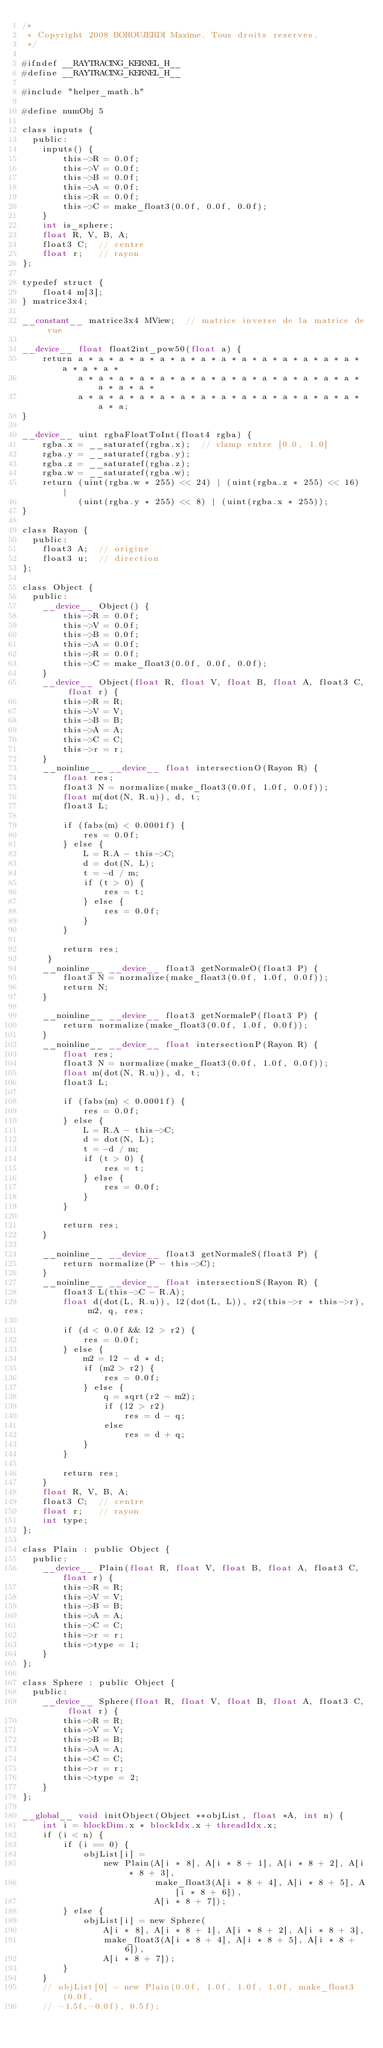Convert code to text. <code><loc_0><loc_0><loc_500><loc_500><_Cuda_>/*
 * Copyright 2008 BOROUJERDI Maxime. Tous droits reserves.
 */

#ifndef __RAYTRACING_KERNEL_H__
#define __RAYTRACING_KERNEL_H__

#include "helper_math.h"

#define numObj 5

class inputs {
  public:
    inputs() {
        this->R = 0.0f;
        this->V = 0.0f;
        this->B = 0.0f;
        this->A = 0.0f;
        this->R = 0.0f;
        this->C = make_float3(0.0f, 0.0f, 0.0f);
    }
    int is_sphere;
    float R, V, B, A;
    float3 C;  // centre
    float r;   // rayon
};

typedef struct {
    float4 m[3];
} matrice3x4;

__constant__ matrice3x4 MView;  // matrice inverse de la matrice de vue

__device__ float float2int_pow50(float a) {
    return a * a * a * a * a * a * a * a * a * a * a * a * a * a * a * a * a *
           a * a * a * a * a * a * a * a * a * a * a * a * a * a * a * a * a *
           a * a * a * a * a * a * a * a * a * a * a * a * a * a * a * a;
}

__device__ uint rgbaFloatToInt(float4 rgba) {
    rgba.x = __saturatef(rgba.x);  // clamp entre [0.0, 1.0]
    rgba.y = __saturatef(rgba.y);
    rgba.z = __saturatef(rgba.z);
    rgba.w = __saturatef(rgba.w);
    return (uint(rgba.w * 255) << 24) | (uint(rgba.z * 255) << 16) |
           (uint(rgba.y * 255) << 8) | (uint(rgba.x * 255));
}

class Rayon {
  public:
    float3 A;  // origine
    float3 u;  // direction
};

class Object {
  public:
    __device__ Object() {
        this->R = 0.0f;
        this->V = 0.0f;
        this->B = 0.0f;
        this->A = 0.0f;
        this->R = 0.0f;
        this->C = make_float3(0.0f, 0.0f, 0.0f);
    }
    __device__ Object(float R, float V, float B, float A, float3 C, float r) {
        this->R = R;
        this->V = V;
        this->B = B;
        this->A = A;
        this->C = C;
        this->r = r;
    }
    __noinline__ __device__ float intersectionO(Rayon R) {
        float res;
        float3 N = normalize(make_float3(0.0f, 1.0f, 0.0f));
        float m(dot(N, R.u)), d, t;
        float3 L;

        if (fabs(m) < 0.0001f) {
            res = 0.0f;
        } else {
            L = R.A - this->C;
            d = dot(N, L);
            t = -d / m;
            if (t > 0) {
                res = t;
            } else {
                res = 0.0f;
            }
        }

        return res;
     }
    __noinline__ __device__ float3 getNormaleO(float3 P) {
        float3 N = normalize(make_float3(0.0f, 1.0f, 0.0f));
        return N;
    }

    __noinline__ __device__ float3 getNormaleP(float3 P) {
        return normalize(make_float3(0.0f, 1.0f, 0.0f));
    }
    __noinline__ __device__ float intersectionP(Rayon R) {
        float res;
        float3 N = normalize(make_float3(0.0f, 1.0f, 0.0f));
        float m(dot(N, R.u)), d, t;
        float3 L;

        if (fabs(m) < 0.0001f) {
            res = 0.0f;
        } else {
            L = R.A - this->C;
            d = dot(N, L);
            t = -d / m;
            if (t > 0) {
                res = t;
            } else {
                res = 0.0f;
            }
        }

        return res;
    }

    __noinline__ __device__ float3 getNormaleS(float3 P) {
        return normalize(P - this->C);
    }
    __noinline__ __device__ float intersectionS(Rayon R) {
        float3 L(this->C - R.A);
        float d(dot(L, R.u)), l2(dot(L, L)), r2(this->r * this->r), m2, q, res;

        if (d < 0.0f && l2 > r2) {
            res = 0.0f;
        } else {
            m2 = l2 - d * d;
            if (m2 > r2) {
                res = 0.0f;
            } else {
                q = sqrt(r2 - m2);
                if (l2 > r2)
                    res = d - q;
                else
                    res = d + q;
            }
        }

        return res;
    }
    float R, V, B, A;
    float3 C;  // centre
    float r;   // rayon
    int type;
};

class Plain : public Object {
  public:
    __device__ Plain(float R, float V, float B, float A, float3 C, float r) {
        this->R = R;
        this->V = V;
        this->B = B;
        this->A = A;
        this->C = C;
        this->r = r;
        this->type = 1;
    }
};

class Sphere : public Object {
  public:
    __device__ Sphere(float R, float V, float B, float A, float3 C, float r) {
        this->R = R;
        this->V = V;
        this->B = B;
        this->A = A;
        this->C = C;
        this->r = r;
        this->type = 2;
    }
};

__global__ void initObject(Object **objList, float *A, int n) {
    int i = blockDim.x * blockIdx.x + threadIdx.x;
    if (i < n) {
        if (i == 0) {
            objList[i] =
                new Plain(A[i * 8], A[i * 8 + 1], A[i * 8 + 2], A[i * 8 + 3],
                          make_float3(A[i * 8 + 4], A[i * 8 + 5], A[i * 8 + 6]),
                          A[i * 8 + 7]);
        } else {
            objList[i] = new Sphere(
                A[i * 8], A[i * 8 + 1], A[i * 8 + 2], A[i * 8 + 3],
                make_float3(A[i * 8 + 4], A[i * 8 + 5], A[i * 8 + 6]),
                A[i * 8 + 7]);
        }
    }
    // objList[0] = new Plain(0.0f, 1.0f, 1.0f, 1.0f, make_float3(0.0f,
    // -1.5f,-0.0f), 0.5f);</code> 